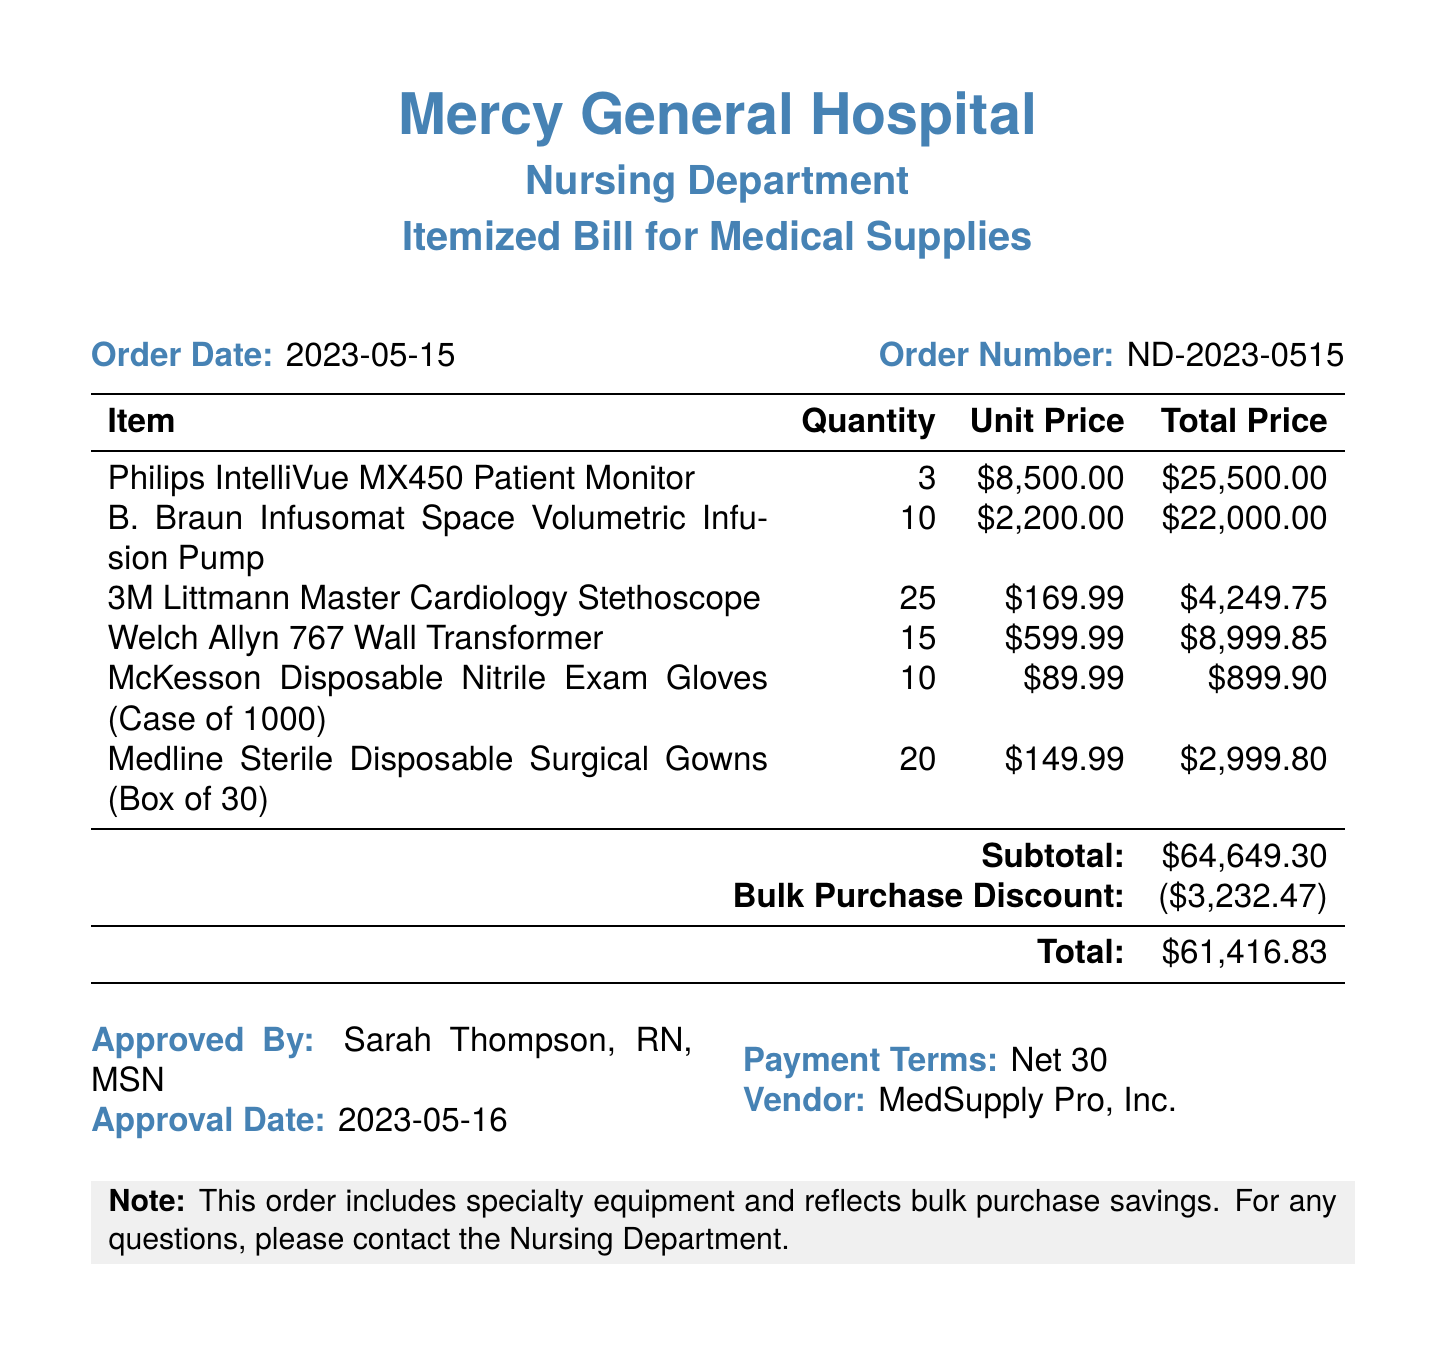What is the order date? The order date is specified in the document under "Order Date."
Answer: 2023-05-15 Who approved the bill? The name of the person who approved the bill is at the end of the document under "Approved By."
Answer: Sarah Thompson, RN, MSN How many Philips IntelliVue MX450 Patient Monitors were ordered? The quantity of the Philips IntelliVue MX450 Patient Monitors is listed in the itemized table.
Answer: 3 What is the total price after applying the bulk purchase discount? The total price is clearly indicated in the itemized section after the bulk purchase discount.
Answer: $61,416.83 What is the subtotal amount before the discount? The subtotal amount is mentioned in the document just before the bulk purchase discount section.
Answer: $64,649.30 What payment terms are specified in the document? The payment terms can be found in the "Payment Terms" section of the document.
Answer: Net 30 How many B. Braun Infusomat Space Volumetric Infusion Pumps were ordered? The quantity for B. Braun Infusomat Space Volumetric Infusion Pumps is listed in the itemized bill.
Answer: 10 What is the vendor's name? The vendor's name is provided in the "Vendor" section at the bottom of the document.
Answer: MedSupply Pro, Inc What note is provided at the bottom of the document? The document contains a note that highlights specific information about the order.
Answer: This order includes specialty equipment and reflects bulk purchase savings 